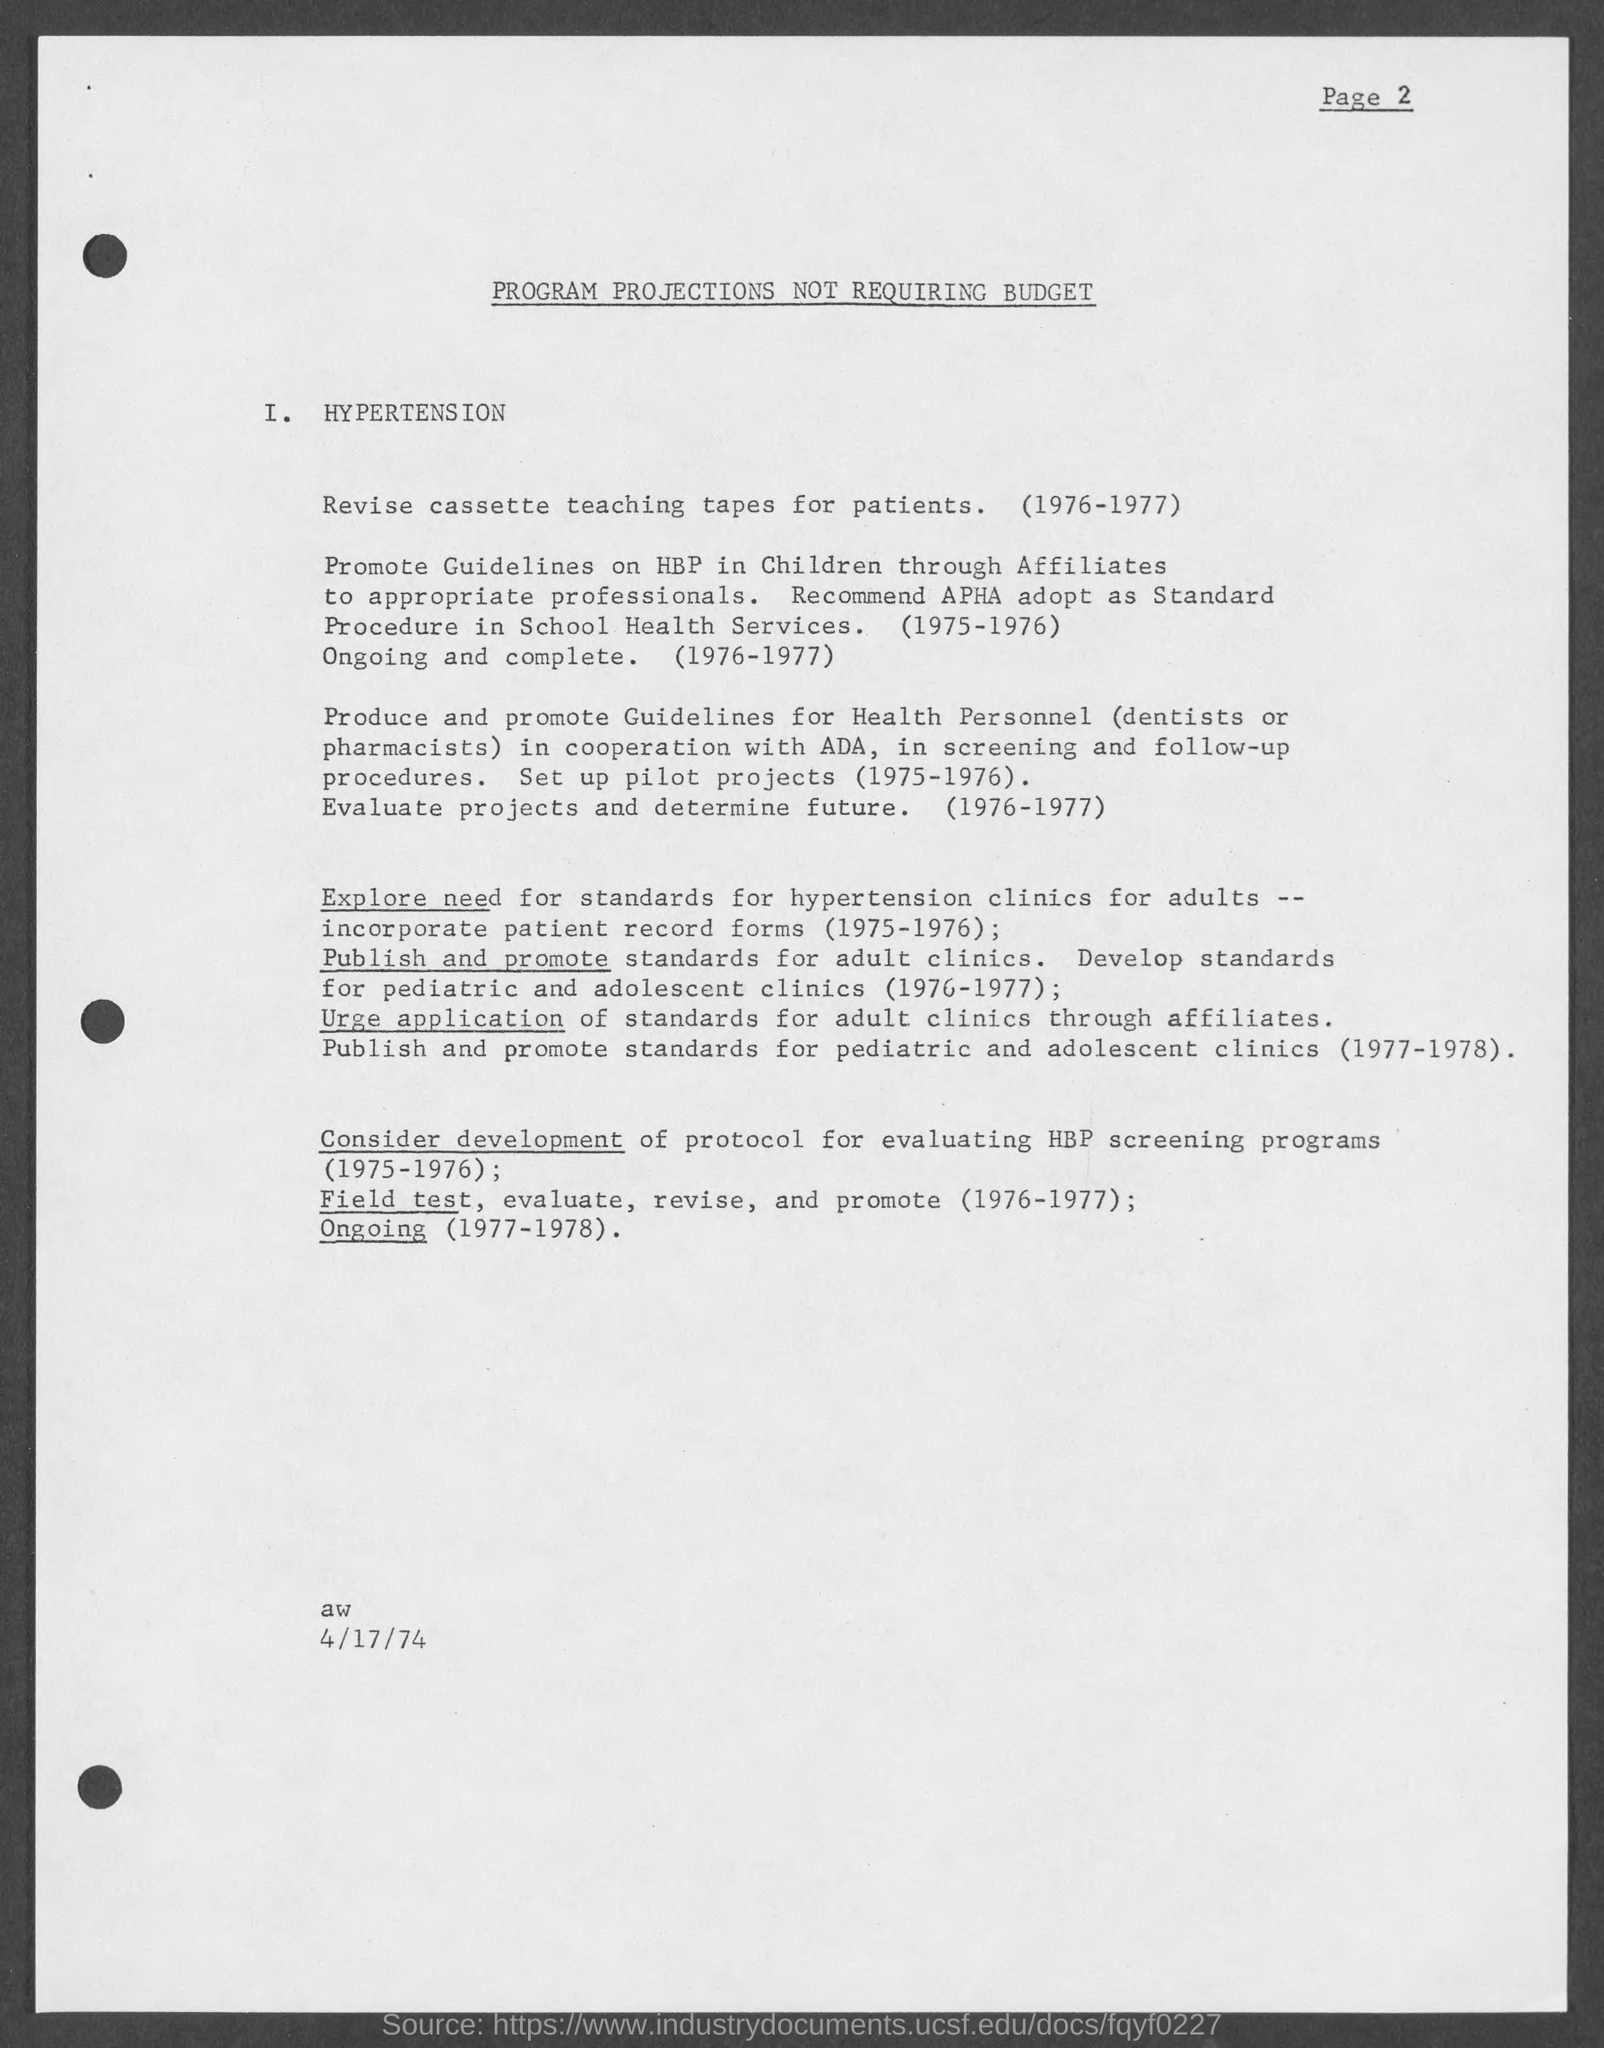Specify some key components in this picture. The date mentioned in this document is 4/17/74. 